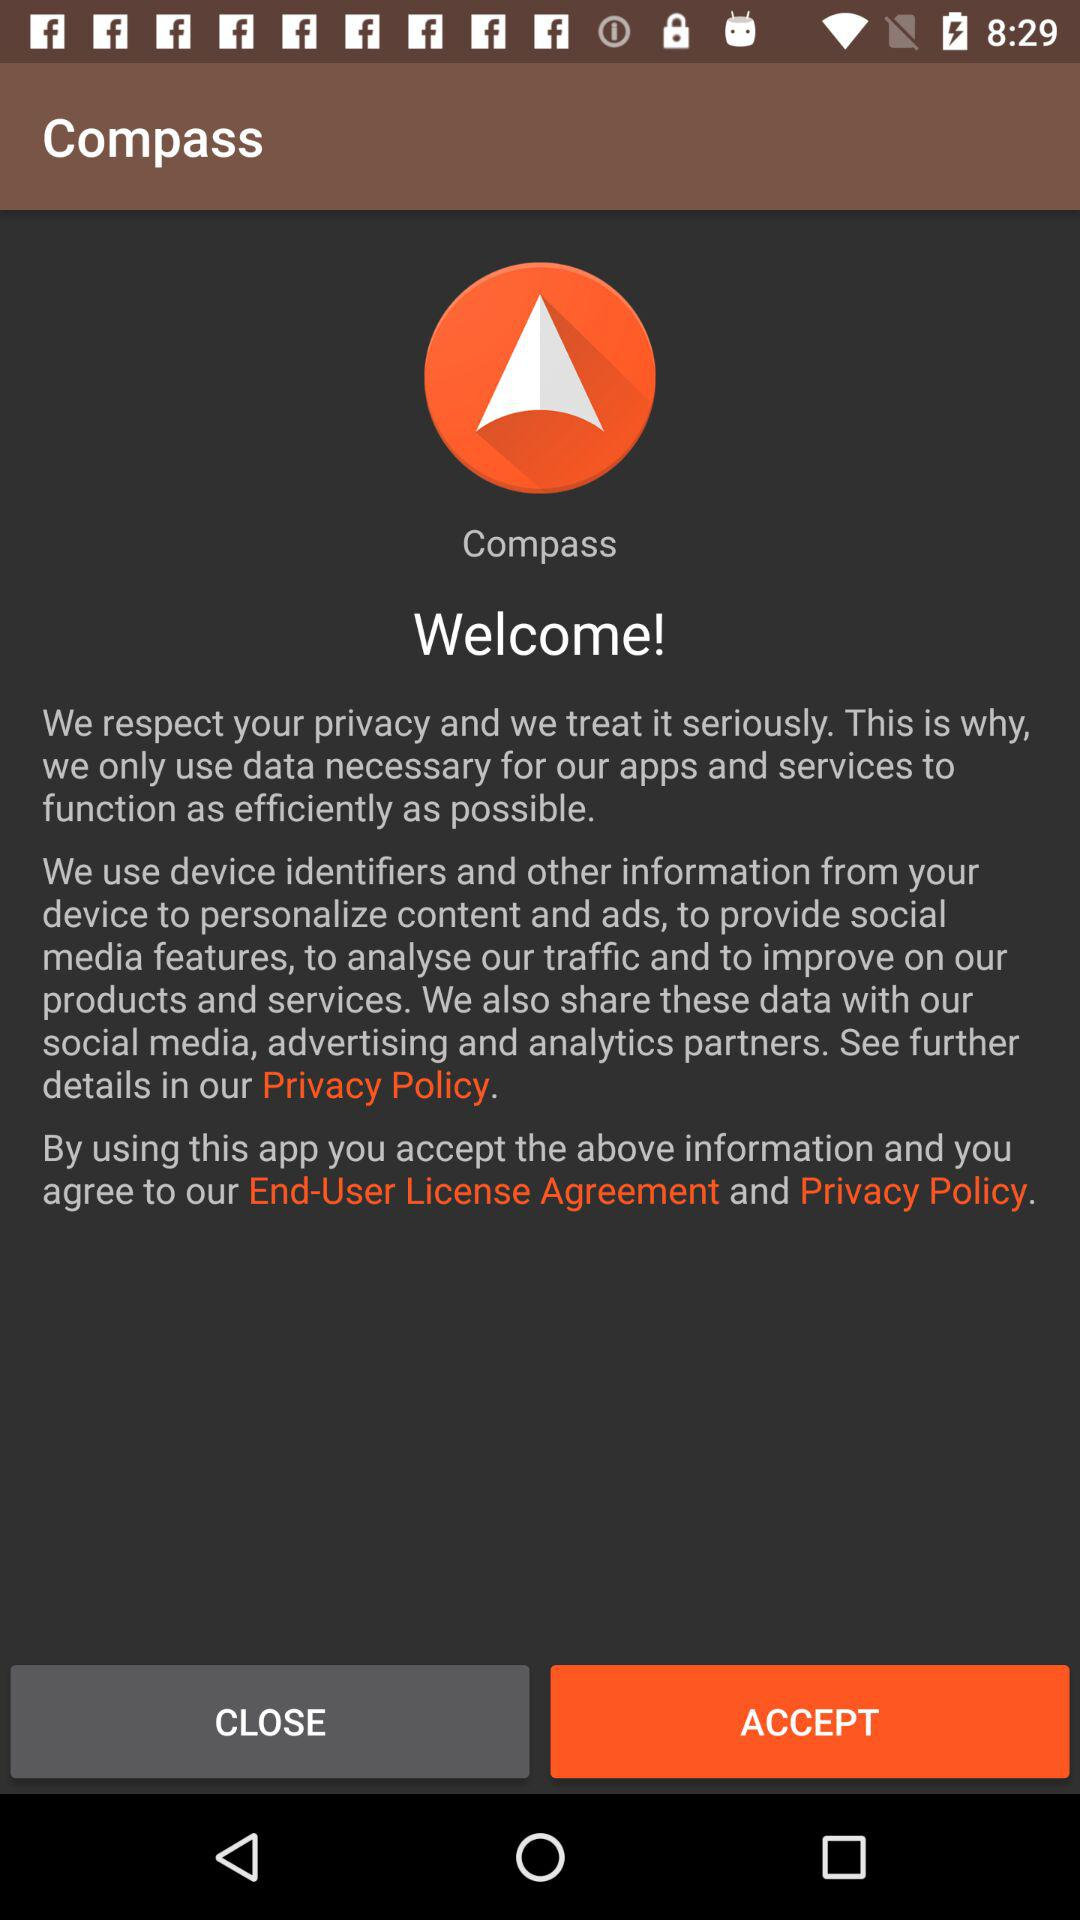What is the application name? The application name is "Compass". 